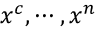<formula> <loc_0><loc_0><loc_500><loc_500>x ^ { c } , \cdots , x ^ { n }</formula> 